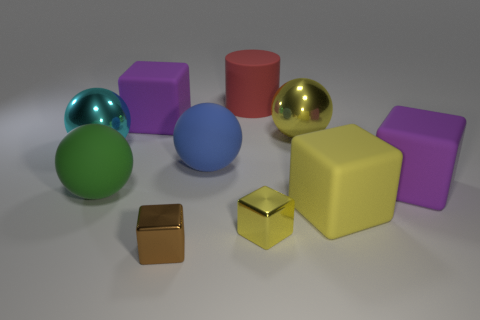What number of rubber things are cylinders or green balls?
Make the answer very short. 2. The blue object has what shape?
Your answer should be compact. Sphere. There is a cyan sphere that is the same size as the green matte sphere; what is it made of?
Your answer should be very brief. Metal. What number of large things are green rubber objects or brown metal balls?
Your response must be concise. 1. Is there a big cyan shiny sphere?
Give a very brief answer. Yes. What size is the green object that is made of the same material as the large blue sphere?
Ensure brevity in your answer.  Large. Is the material of the big red thing the same as the tiny yellow block?
Offer a very short reply. No. How many other objects are there of the same material as the large green object?
Ensure brevity in your answer.  5. What number of shiny things are right of the brown thing and in front of the blue object?
Your answer should be very brief. 1. What is the color of the cylinder?
Your answer should be very brief. Red. 